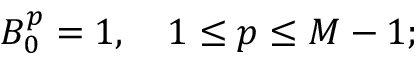Convert formula to latex. <formula><loc_0><loc_0><loc_500><loc_500>B _ { 0 } ^ { p } = 1 , \quad 1 \leq p \leq M - 1 ;</formula> 